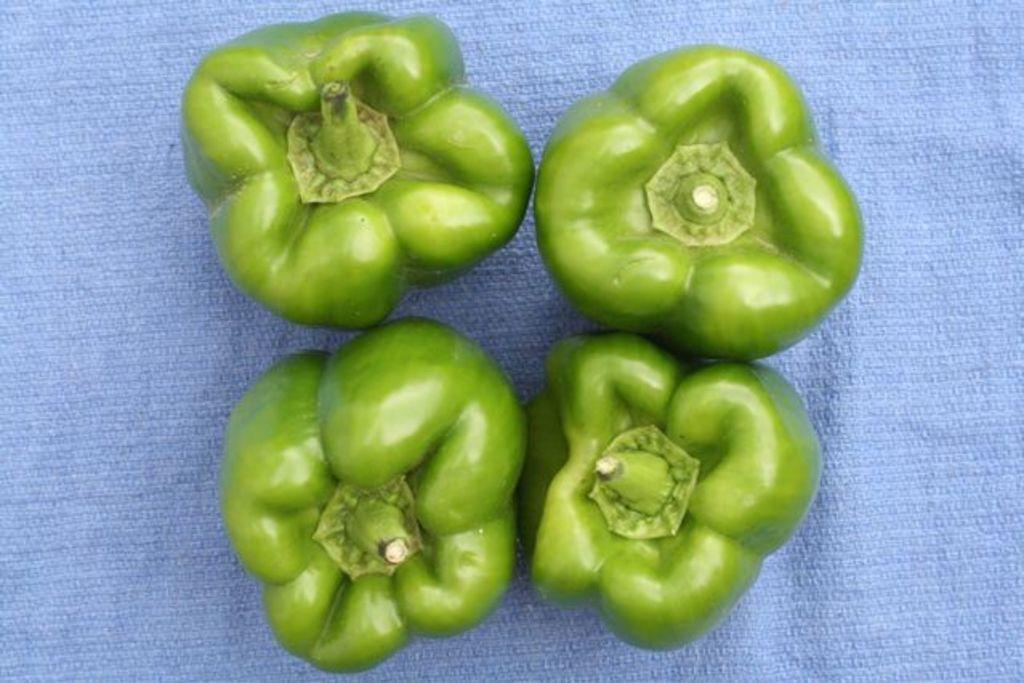What type of food items are present in the image? There are vegetables in the image. How are the vegetables arranged or displayed in the image? The vegetables are placed on a blue color cloth. What musical instrument is being played by the vegetables in the image? There is no musical instrument or any indication of music in the image; it only features vegetables placed on a blue color cloth. 